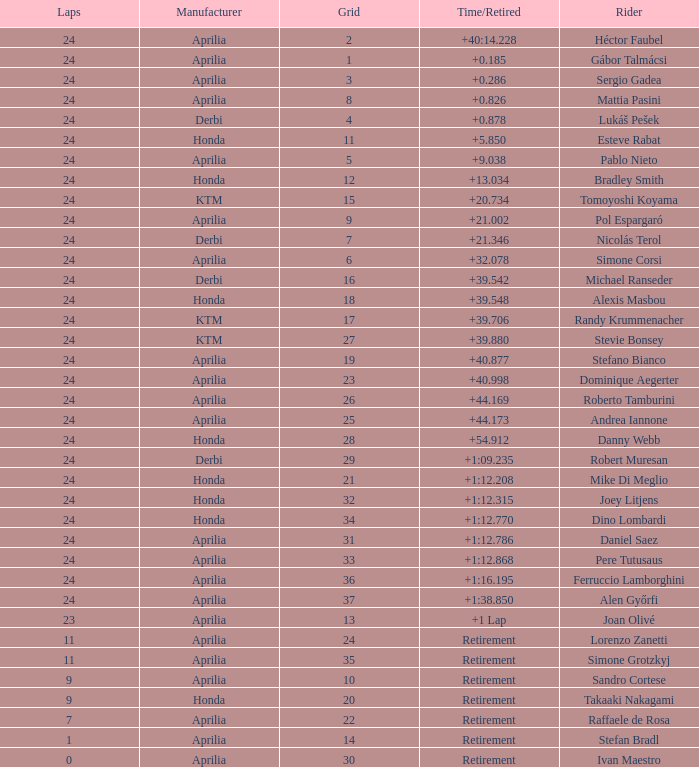Who manufactured the motorcycle that did 24 laps and 9 grids? Aprilia. 